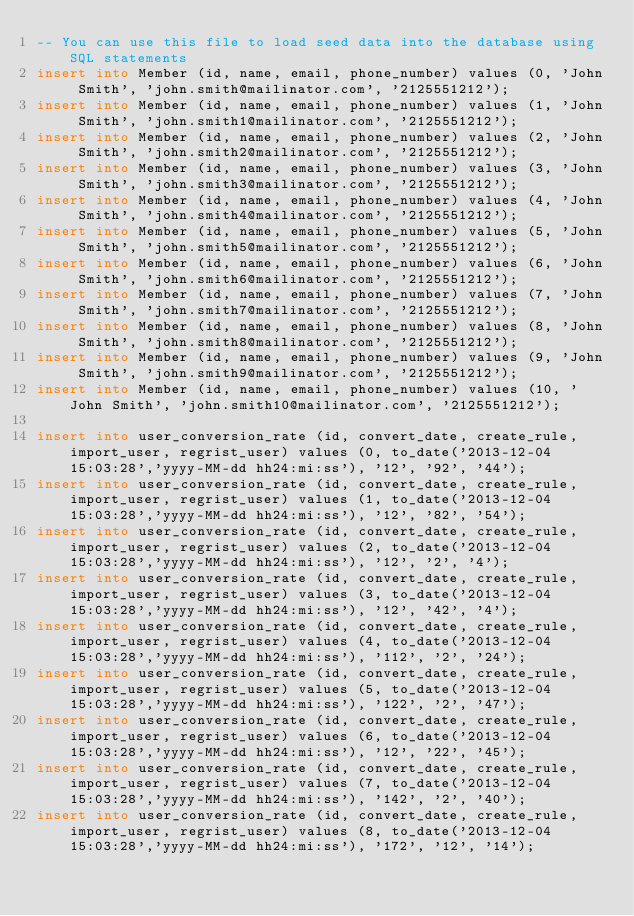<code> <loc_0><loc_0><loc_500><loc_500><_SQL_>-- You can use this file to load seed data into the database using SQL statements
insert into Member (id, name, email, phone_number) values (0, 'John Smith', 'john.smith@mailinator.com', '2125551212');
insert into Member (id, name, email, phone_number) values (1, 'John Smith', 'john.smith1@mailinator.com', '2125551212');
insert into Member (id, name, email, phone_number) values (2, 'John Smith', 'john.smith2@mailinator.com', '2125551212');
insert into Member (id, name, email, phone_number) values (3, 'John Smith', 'john.smith3@mailinator.com', '2125551212');
insert into Member (id, name, email, phone_number) values (4, 'John Smith', 'john.smith4@mailinator.com', '2125551212');
insert into Member (id, name, email, phone_number) values (5, 'John Smith', 'john.smith5@mailinator.com', '2125551212');
insert into Member (id, name, email, phone_number) values (6, 'John Smith', 'john.smith6@mailinator.com', '2125551212');
insert into Member (id, name, email, phone_number) values (7, 'John Smith', 'john.smith7@mailinator.com', '2125551212');
insert into Member (id, name, email, phone_number) values (8, 'John Smith', 'john.smith8@mailinator.com', '2125551212');
insert into Member (id, name, email, phone_number) values (9, 'John Smith', 'john.smith9@mailinator.com', '2125551212');
insert into Member (id, name, email, phone_number) values (10, 'John Smith', 'john.smith10@mailinator.com', '2125551212');

insert into user_conversion_rate (id, convert_date, create_rule, import_user, regrist_user) values (0, to_date('2013-12-04 15:03:28','yyyy-MM-dd hh24:mi:ss'), '12', '92', '44');
insert into user_conversion_rate (id, convert_date, create_rule, import_user, regrist_user) values (1, to_date('2013-12-04 15:03:28','yyyy-MM-dd hh24:mi:ss'), '12', '82', '54');
insert into user_conversion_rate (id, convert_date, create_rule, import_user, regrist_user) values (2, to_date('2013-12-04 15:03:28','yyyy-MM-dd hh24:mi:ss'), '12', '2', '4');
insert into user_conversion_rate (id, convert_date, create_rule, import_user, regrist_user) values (3, to_date('2013-12-04 15:03:28','yyyy-MM-dd hh24:mi:ss'), '12', '42', '4');
insert into user_conversion_rate (id, convert_date, create_rule, import_user, regrist_user) values (4, to_date('2013-12-04 15:03:28','yyyy-MM-dd hh24:mi:ss'), '112', '2', '24');
insert into user_conversion_rate (id, convert_date, create_rule, import_user, regrist_user) values (5, to_date('2013-12-04 15:03:28','yyyy-MM-dd hh24:mi:ss'), '122', '2', '47');
insert into user_conversion_rate (id, convert_date, create_rule, import_user, regrist_user) values (6, to_date('2013-12-04 15:03:28','yyyy-MM-dd hh24:mi:ss'), '12', '22', '45');
insert into user_conversion_rate (id, convert_date, create_rule, import_user, regrist_user) values (7, to_date('2013-12-04 15:03:28','yyyy-MM-dd hh24:mi:ss'), '142', '2', '40');
insert into user_conversion_rate (id, convert_date, create_rule, import_user, regrist_user) values (8, to_date('2013-12-04 15:03:28','yyyy-MM-dd hh24:mi:ss'), '172', '12', '14');</code> 